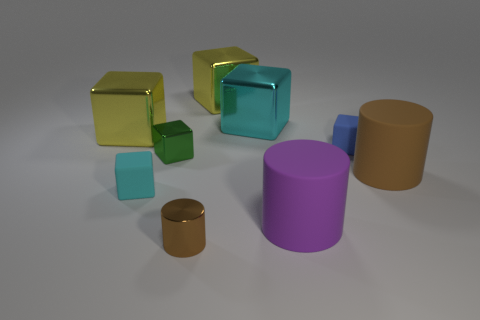What size is the object that is the same color as the metallic cylinder?
Offer a terse response. Large. Are there any large blocks of the same color as the metallic cylinder?
Give a very brief answer. No. What is the color of the matte object that is the same size as the blue matte cube?
Give a very brief answer. Cyan. There is a big matte cylinder behind the tiny cyan cube; is there a blue rubber thing behind it?
Offer a very short reply. Yes. What material is the small cube in front of the green shiny block?
Offer a very short reply. Rubber. Are the big cube behind the large cyan cube and the brown object on the left side of the blue rubber object made of the same material?
Your response must be concise. Yes. Is the number of tiny green metal blocks right of the big purple matte cylinder the same as the number of blue matte cubes to the right of the tiny green block?
Provide a short and direct response. No. What number of cyan objects are made of the same material as the blue cube?
Your answer should be very brief. 1. What is the shape of the large matte object that is the same color as the small cylinder?
Your answer should be very brief. Cylinder. There is a metallic cube behind the cyan block behind the green cube; what is its size?
Provide a short and direct response. Large. 